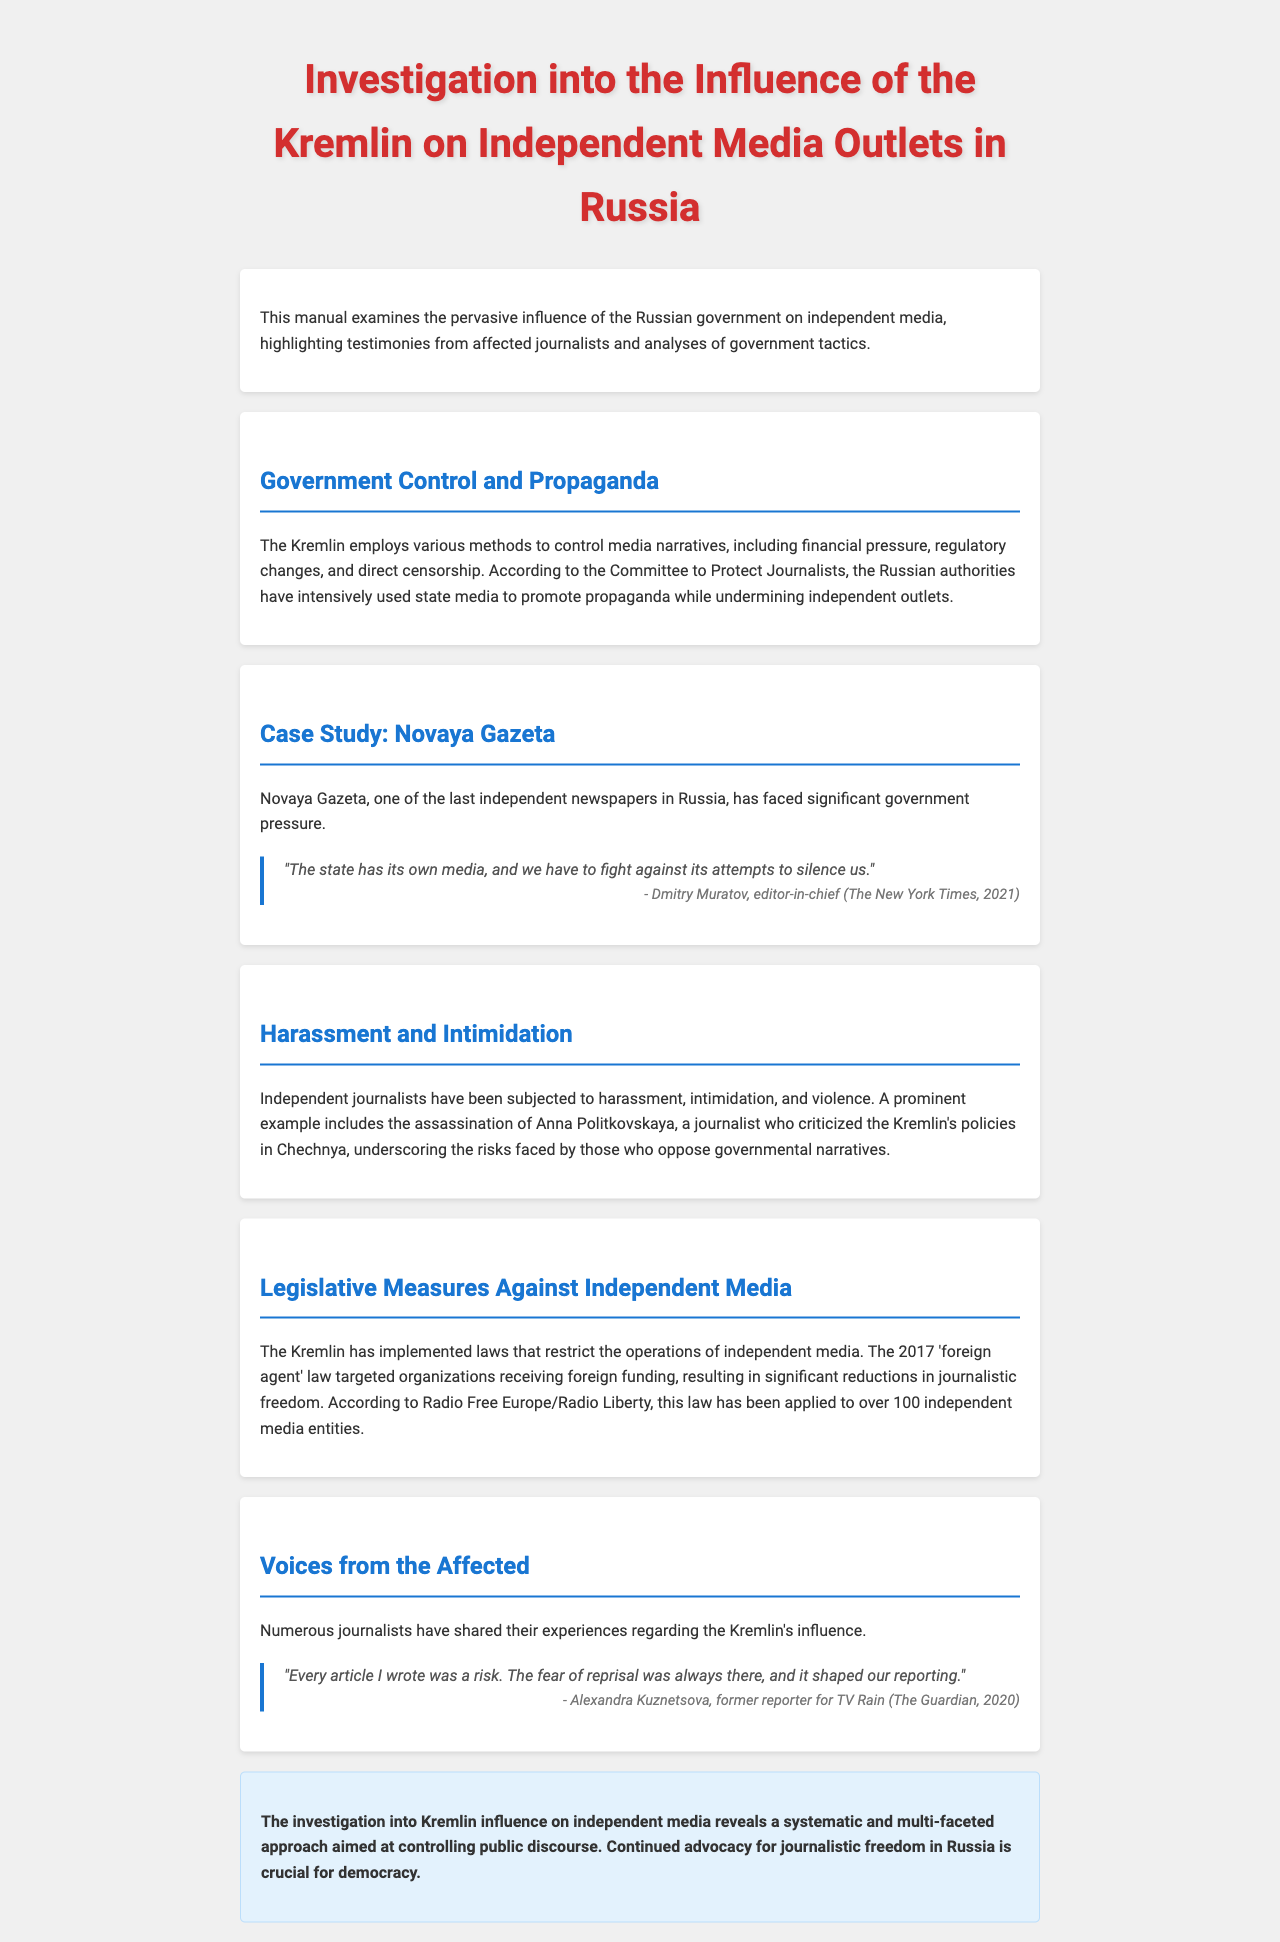what is the title of the document? The title of the document is presented in the main heading at the top of the manual.
Answer: Investigation into the Influence of the Kremlin on Independent Media Outlets in Russia who is the editor-in-chief of Novaya Gazeta? The document provides a quote attributed to Dmitry Muratov, who is identified as the editor-in-chief of Novaya Gazeta.
Answer: Dmitry Muratov which law was implemented in 2017 against independent media? The document mentions a specific law that was targeted against independent media outlets operating in Russia.
Answer: 'foreign agent' law how many independent media entities have been affected by the 'foreign agent' law? The document states that the law has been applied to a specific number of independent media entities.
Answer: over 100 which journalist was assassinated for criticizing the Kremlin's policies? The document references a specific journalist who faced assassination due to her criticisms of the Kremlin.
Answer: Anna Politkovskaya how does Alexandra Kuznetsova describe her experience as a journalist? A quote in the document summarizes the sentiment expressed by Alexandra Kuznetsova regarding her work as a journalist under the Kremlin's influence.
Answer: "Every article I wrote was a risk." what is the focus of the investigation mentioned in the conclusion? The conclusion highlights the main theme of the investigation into governmental influence, providing a focus for the reader.
Answer: Kremlin influence on independent media what organization reported on the media control tactics used by the Kremlin? A specific organization is mentioned in the document that has analyzed and reported on the Kremlin's media control tactics.
Answer: Committee to Protect Journalists 